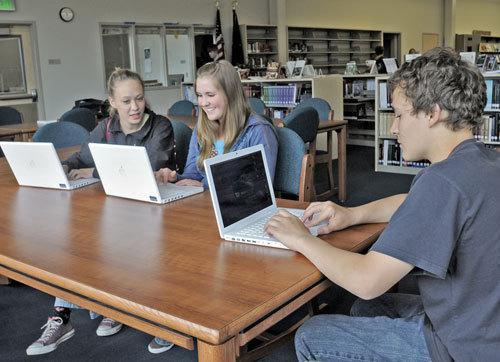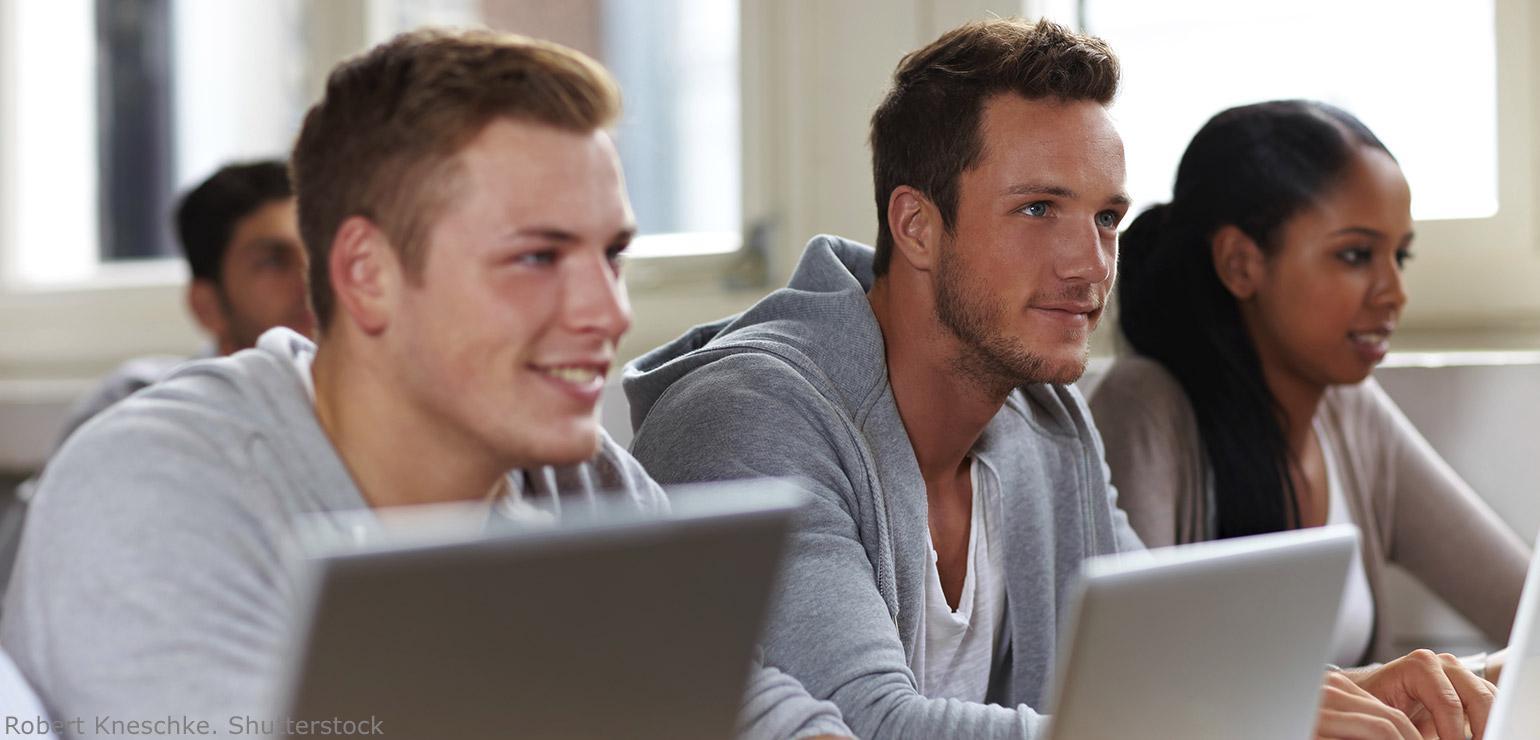The first image is the image on the left, the second image is the image on the right. Examine the images to the left and right. Is the description "The left image shows a person leaning in to look at an open laptop in front of a different person, and the right image includes a man in a necktie sitting behind a laptop." accurate? Answer yes or no. No. The first image is the image on the left, the second image is the image on the right. Assess this claim about the two images: "The right image contains a man wearing a white shirt with a black tie.". Correct or not? Answer yes or no. No. 